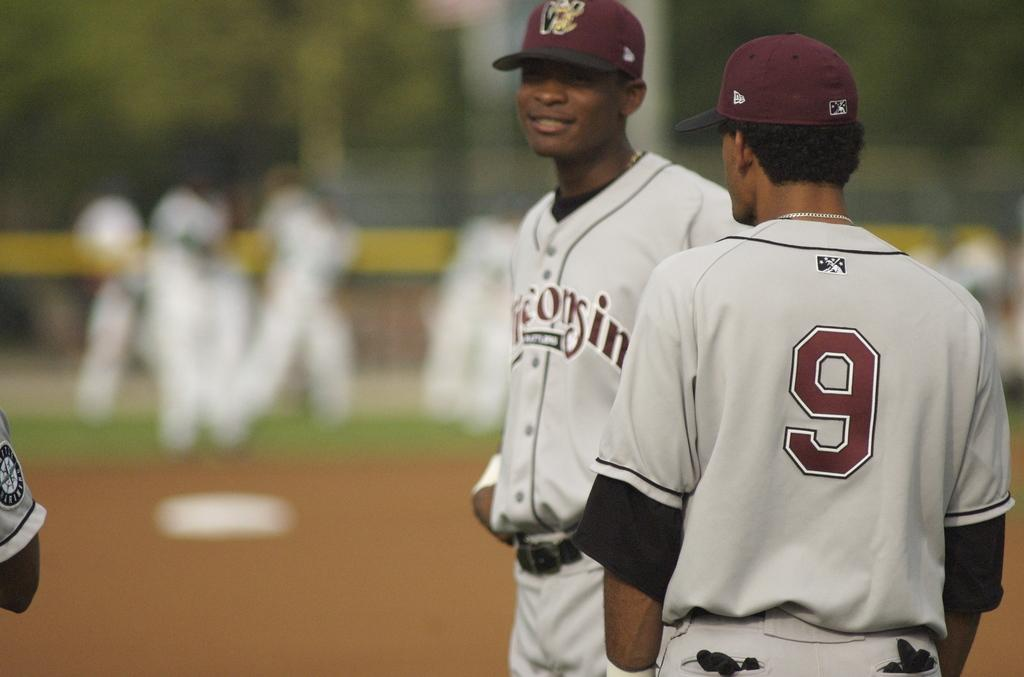Provide a one-sentence caption for the provided image. The player next to player number number 9 is smiling. 